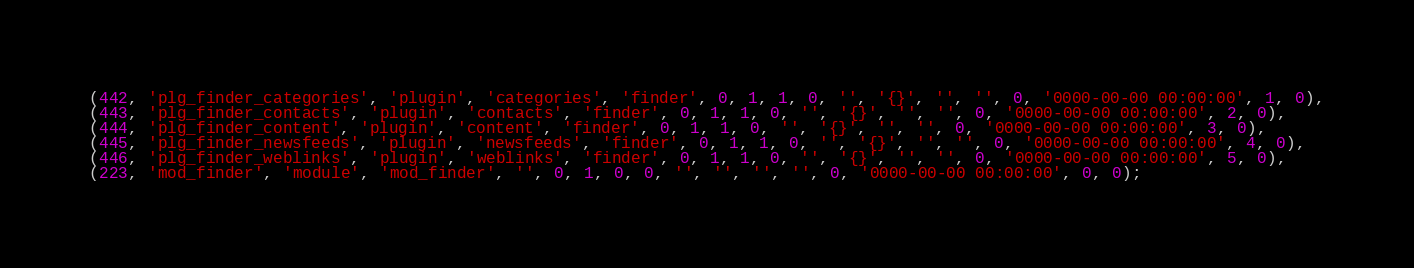<code> <loc_0><loc_0><loc_500><loc_500><_SQL_>(442, 'plg_finder_categories', 'plugin', 'categories', 'finder', 0, 1, 1, 0, '', '{}', '', '', 0, '0000-00-00 00:00:00', 1, 0),
(443, 'plg_finder_contacts', 'plugin', 'contacts', 'finder', 0, 1, 1, 0, '', '{}', '', '', 0, '0000-00-00 00:00:00', 2, 0),
(444, 'plg_finder_content', 'plugin', 'content', 'finder', 0, 1, 1, 0, '', '{}', '', '', 0, '0000-00-00 00:00:00', 3, 0),
(445, 'plg_finder_newsfeeds', 'plugin', 'newsfeeds', 'finder', 0, 1, 1, 0, '', '{}', '', '', 0, '0000-00-00 00:00:00', 4, 0),
(446, 'plg_finder_weblinks', 'plugin', 'weblinks', 'finder', 0, 1, 1, 0, '', '{}', '', '', 0, '0000-00-00 00:00:00', 5, 0),
(223, 'mod_finder', 'module', 'mod_finder', '', 0, 1, 0, 0, '', '', '', '', 0, '0000-00-00 00:00:00', 0, 0);
</code> 